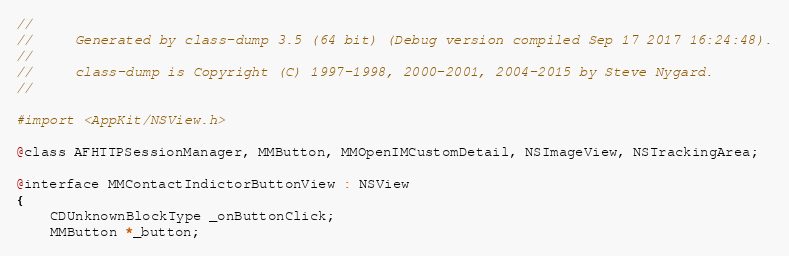Convert code to text. <code><loc_0><loc_0><loc_500><loc_500><_C_>//
//     Generated by class-dump 3.5 (64 bit) (Debug version compiled Sep 17 2017 16:24:48).
//
//     class-dump is Copyright (C) 1997-1998, 2000-2001, 2004-2015 by Steve Nygard.
//

#import <AppKit/NSView.h>

@class AFHTTPSessionManager, MMButton, MMOpenIMCustomDetail, NSImageView, NSTrackingArea;

@interface MMContactIndictorButtonView : NSView
{
    CDUnknownBlockType _onButtonClick;
    MMButton *_button;</code> 